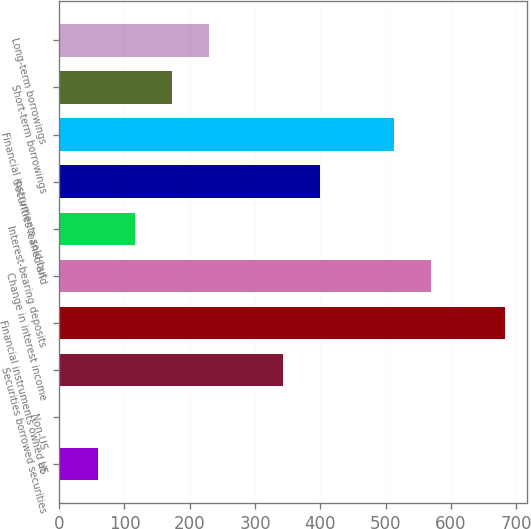<chart> <loc_0><loc_0><loc_500><loc_500><bar_chart><fcel>US<fcel>Non-US<fcel>Securities borrowed securities<fcel>Financial instruments owned at<fcel>Change in interest income<fcel>Interest-bearing deposits<fcel>Securities loaned and<fcel>Financial instruments sold but<fcel>Short-term borrowings<fcel>Long-term borrowings<nl><fcel>58.7<fcel>2<fcel>342.2<fcel>682.4<fcel>569<fcel>115.4<fcel>398.9<fcel>512.3<fcel>172.1<fcel>228.8<nl></chart> 